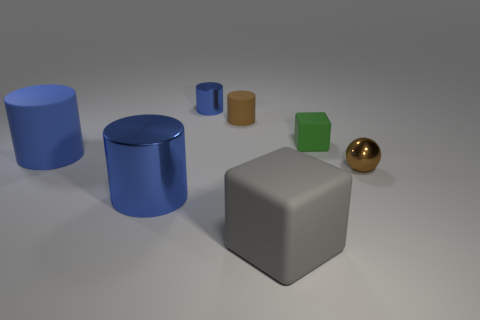There is a brown object that is behind the small green cube; is it the same shape as the large gray rubber thing?
Make the answer very short. No. There is a large rubber object that is the same color as the tiny shiny cylinder; what is its shape?
Give a very brief answer. Cylinder. The green cube that is the same material as the large gray block is what size?
Make the answer very short. Small. The matte object that is the same color as the large metallic cylinder is what size?
Give a very brief answer. Large. Is the small blue shiny thing the same shape as the brown shiny object?
Your response must be concise. No. Is the number of green rubber objects that are behind the small blue shiny cylinder the same as the number of tiny blue shiny objects that are behind the blue matte cylinder?
Give a very brief answer. No. How many other things are the same shape as the brown shiny object?
Your answer should be compact. 0. Do the block behind the big blue rubber object and the block that is in front of the brown metallic object have the same size?
Give a very brief answer. No. How many blocks are either tiny red rubber things or tiny matte objects?
Ensure brevity in your answer.  1. What number of matte objects are either tiny green objects or small blue cylinders?
Offer a very short reply. 1. 